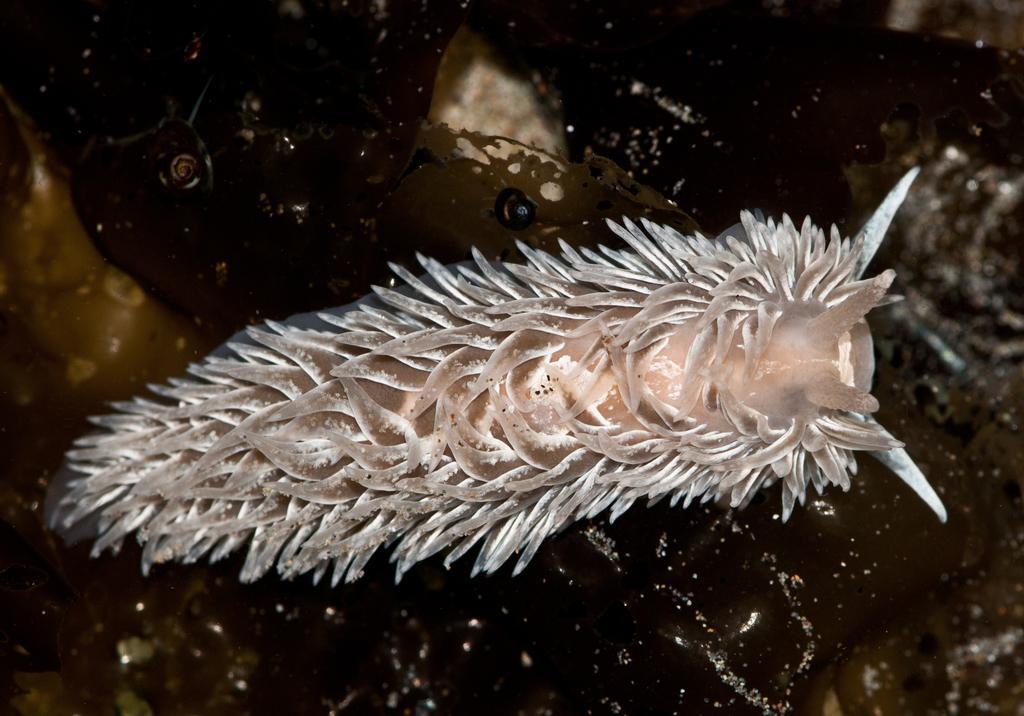Can you describe this image briefly? In this image, in the middle, we can see an insect. In the background, we can see black color and yellow color. 